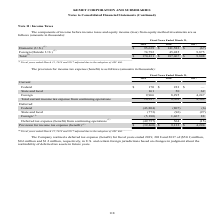According to Kemet Corporation's financial document, How much was the deferred tax expense (benefit) in 2017? According to the financial document, $1.2 million. The relevant text states: "$0.6 million and $1.2 million, respectively, in U.S. and certain foreign jurisdictions based on changes in judgment about the rea..." Also, What was the current federal income tax expense(benefit) in 2019? According to the financial document, 170 (in thousands). The relevant text states: "Total (1) $ 170,431 $ 187,067 $ 9,808..." Also, What was the current State and Local income tax expense (benefit) in 2017? According to the financial document, 62 (in thousands). The relevant text states: "State and local 161 50 62..." Also, How many years did Total current income tax expense from continuing operations exceed $10,000 thousand? Based on the analysis, there are 1 instances. The counting process: 2019. Also, can you calculate: What was the change in current foreign income tax expense between 2017 and 2018? Based on the calculation: 8,295-4,247, the result is 4048 (in thousands). This is based on the information: "Foreign 9,966 8,295 4,247 Foreign 9,966 8,295 4,247..." The key data points involved are: 4,247, 8,295. Also, can you calculate: What was the percentage change in the deferred federal income tax expense between 2018 and 2019? To answer this question, I need to perform calculations using the financial data. The calculation is: (-43,804-(-807))/-807, which equals 5328 (percentage). This is based on the information: "Federal (43,804) (807) (6) Federal (43,804) (807) (6)..." The key data points involved are: 43,804, 807. 